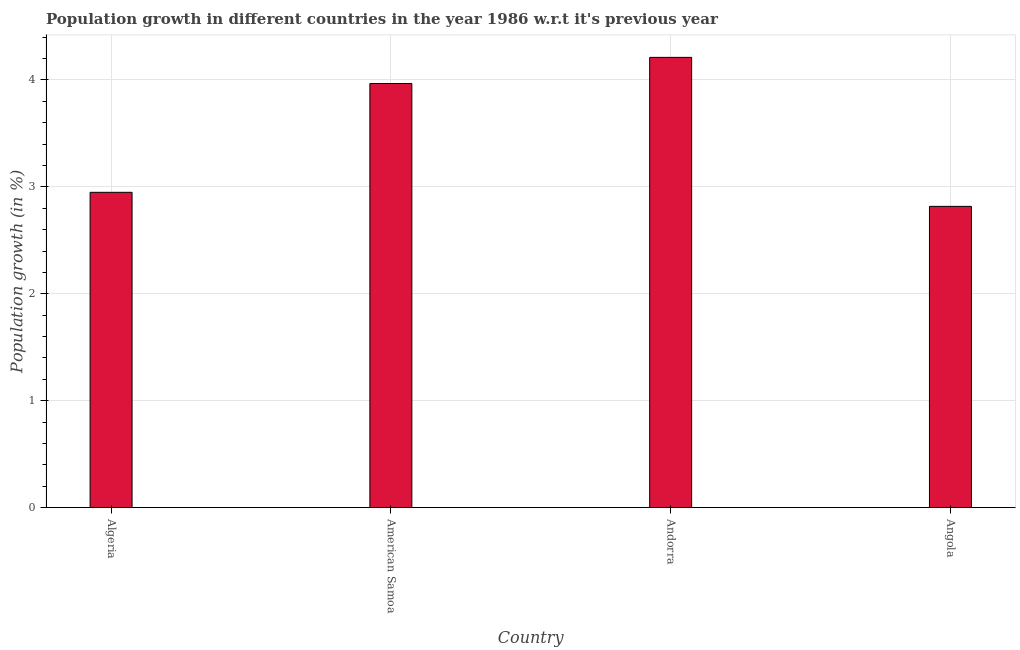Does the graph contain any zero values?
Provide a short and direct response. No. What is the title of the graph?
Your answer should be compact. Population growth in different countries in the year 1986 w.r.t it's previous year. What is the label or title of the Y-axis?
Your answer should be very brief. Population growth (in %). What is the population growth in Algeria?
Offer a very short reply. 2.95. Across all countries, what is the maximum population growth?
Make the answer very short. 4.21. Across all countries, what is the minimum population growth?
Your answer should be compact. 2.82. In which country was the population growth maximum?
Ensure brevity in your answer.  Andorra. In which country was the population growth minimum?
Your answer should be compact. Angola. What is the sum of the population growth?
Offer a terse response. 13.94. What is the difference between the population growth in American Samoa and Angola?
Provide a short and direct response. 1.15. What is the average population growth per country?
Make the answer very short. 3.49. What is the median population growth?
Your answer should be compact. 3.46. What is the ratio of the population growth in Algeria to that in Angola?
Your response must be concise. 1.05. Is the population growth in Algeria less than that in Angola?
Give a very brief answer. No. Is the difference between the population growth in Algeria and American Samoa greater than the difference between any two countries?
Your answer should be compact. No. What is the difference between the highest and the second highest population growth?
Keep it short and to the point. 0.24. Is the sum of the population growth in Algeria and Andorra greater than the maximum population growth across all countries?
Provide a succinct answer. Yes. What is the difference between the highest and the lowest population growth?
Keep it short and to the point. 1.39. In how many countries, is the population growth greater than the average population growth taken over all countries?
Your answer should be very brief. 2. How many bars are there?
Give a very brief answer. 4. Are all the bars in the graph horizontal?
Provide a succinct answer. No. Are the values on the major ticks of Y-axis written in scientific E-notation?
Make the answer very short. No. What is the Population growth (in %) of Algeria?
Make the answer very short. 2.95. What is the Population growth (in %) in American Samoa?
Provide a short and direct response. 3.97. What is the Population growth (in %) of Andorra?
Offer a very short reply. 4.21. What is the Population growth (in %) of Angola?
Your answer should be compact. 2.82. What is the difference between the Population growth (in %) in Algeria and American Samoa?
Your answer should be very brief. -1.02. What is the difference between the Population growth (in %) in Algeria and Andorra?
Provide a succinct answer. -1.26. What is the difference between the Population growth (in %) in Algeria and Angola?
Your answer should be very brief. 0.13. What is the difference between the Population growth (in %) in American Samoa and Andorra?
Offer a very short reply. -0.24. What is the difference between the Population growth (in %) in American Samoa and Angola?
Your response must be concise. 1.15. What is the difference between the Population growth (in %) in Andorra and Angola?
Your response must be concise. 1.39. What is the ratio of the Population growth (in %) in Algeria to that in American Samoa?
Provide a succinct answer. 0.74. What is the ratio of the Population growth (in %) in Algeria to that in Angola?
Make the answer very short. 1.05. What is the ratio of the Population growth (in %) in American Samoa to that in Andorra?
Your answer should be compact. 0.94. What is the ratio of the Population growth (in %) in American Samoa to that in Angola?
Provide a succinct answer. 1.41. What is the ratio of the Population growth (in %) in Andorra to that in Angola?
Make the answer very short. 1.49. 